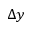<formula> <loc_0><loc_0><loc_500><loc_500>\Delta y</formula> 